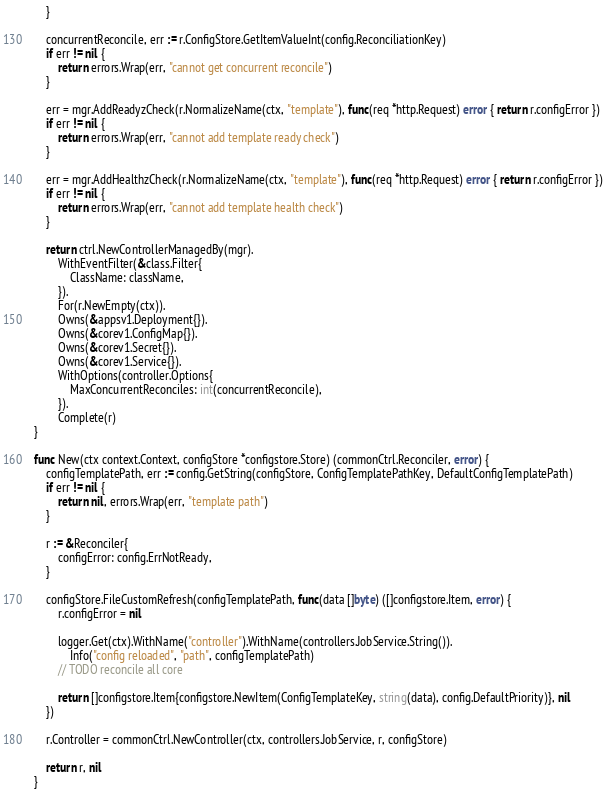Convert code to text. <code><loc_0><loc_0><loc_500><loc_500><_Go_>	}

	concurrentReconcile, err := r.ConfigStore.GetItemValueInt(config.ReconciliationKey)
	if err != nil {
		return errors.Wrap(err, "cannot get concurrent reconcile")
	}

	err = mgr.AddReadyzCheck(r.NormalizeName(ctx, "template"), func(req *http.Request) error { return r.configError })
	if err != nil {
		return errors.Wrap(err, "cannot add template ready check")
	}

	err = mgr.AddHealthzCheck(r.NormalizeName(ctx, "template"), func(req *http.Request) error { return r.configError })
	if err != nil {
		return errors.Wrap(err, "cannot add template health check")
	}

	return ctrl.NewControllerManagedBy(mgr).
		WithEventFilter(&class.Filter{
			ClassName: className,
		}).
		For(r.NewEmpty(ctx)).
		Owns(&appsv1.Deployment{}).
		Owns(&corev1.ConfigMap{}).
		Owns(&corev1.Secret{}).
		Owns(&corev1.Service{}).
		WithOptions(controller.Options{
			MaxConcurrentReconciles: int(concurrentReconcile),
		}).
		Complete(r)
}

func New(ctx context.Context, configStore *configstore.Store) (commonCtrl.Reconciler, error) {
	configTemplatePath, err := config.GetString(configStore, ConfigTemplatePathKey, DefaultConfigTemplatePath)
	if err != nil {
		return nil, errors.Wrap(err, "template path")
	}

	r := &Reconciler{
		configError: config.ErrNotReady,
	}

	configStore.FileCustomRefresh(configTemplatePath, func(data []byte) ([]configstore.Item, error) {
		r.configError = nil

		logger.Get(ctx).WithName("controller").WithName(controllers.JobService.String()).
			Info("config reloaded", "path", configTemplatePath)
		// TODO reconcile all core

		return []configstore.Item{configstore.NewItem(ConfigTemplateKey, string(data), config.DefaultPriority)}, nil
	})

	r.Controller = commonCtrl.NewController(ctx, controllers.JobService, r, configStore)

	return r, nil
}
</code> 